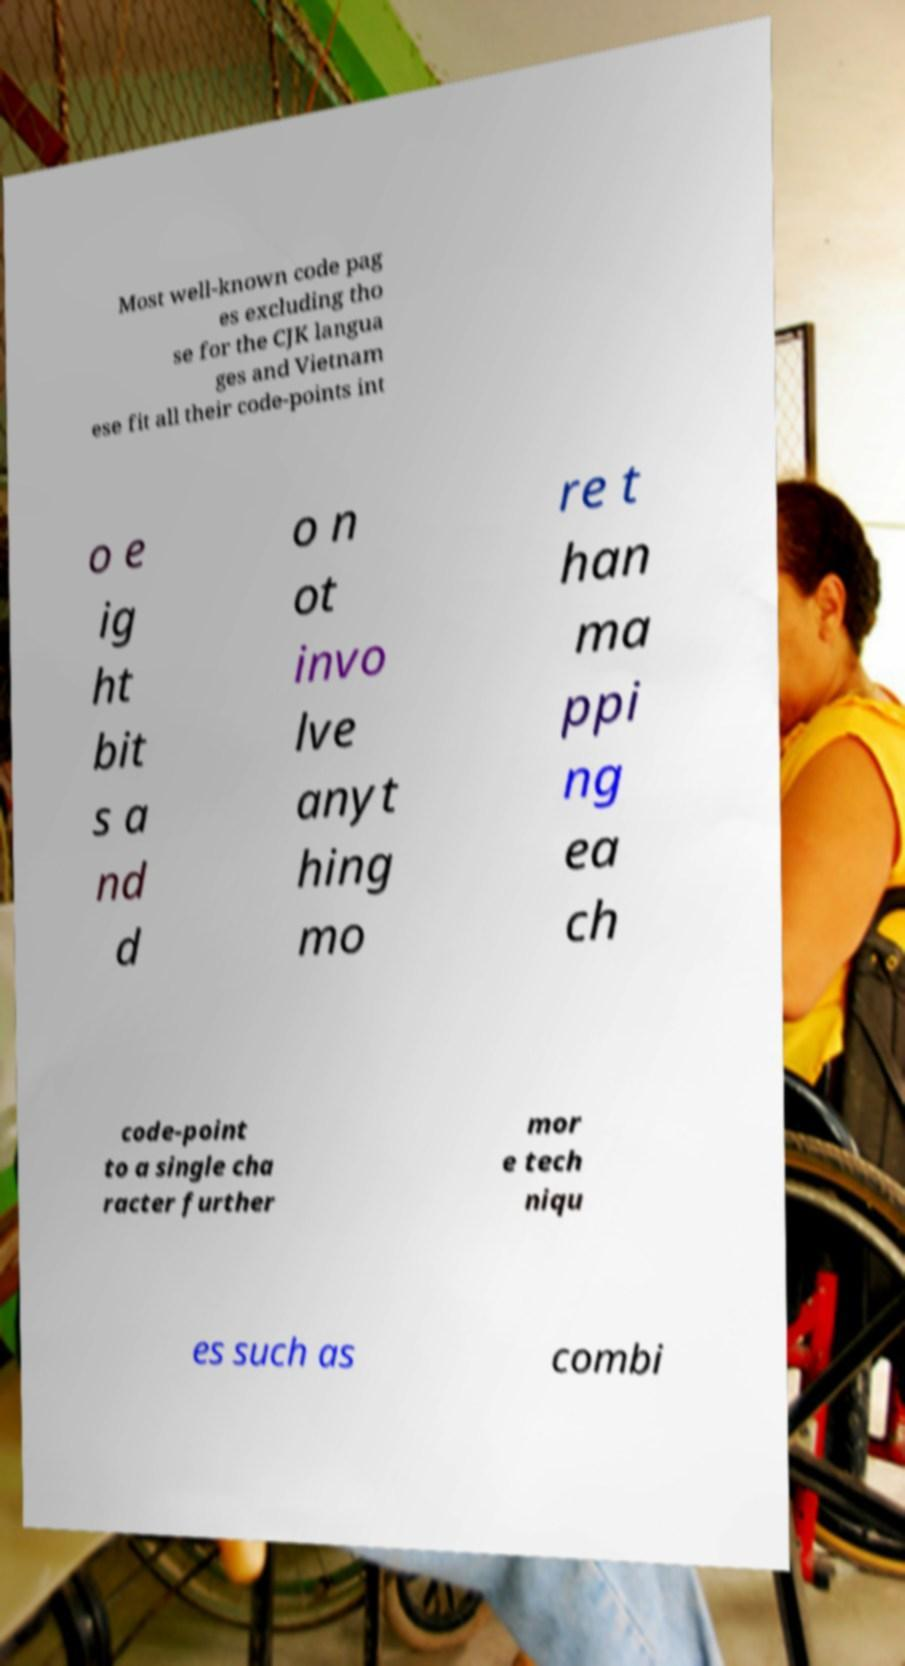There's text embedded in this image that I need extracted. Can you transcribe it verbatim? Most well-known code pag es excluding tho se for the CJK langua ges and Vietnam ese fit all their code-points int o e ig ht bit s a nd d o n ot invo lve anyt hing mo re t han ma ppi ng ea ch code-point to a single cha racter further mor e tech niqu es such as combi 